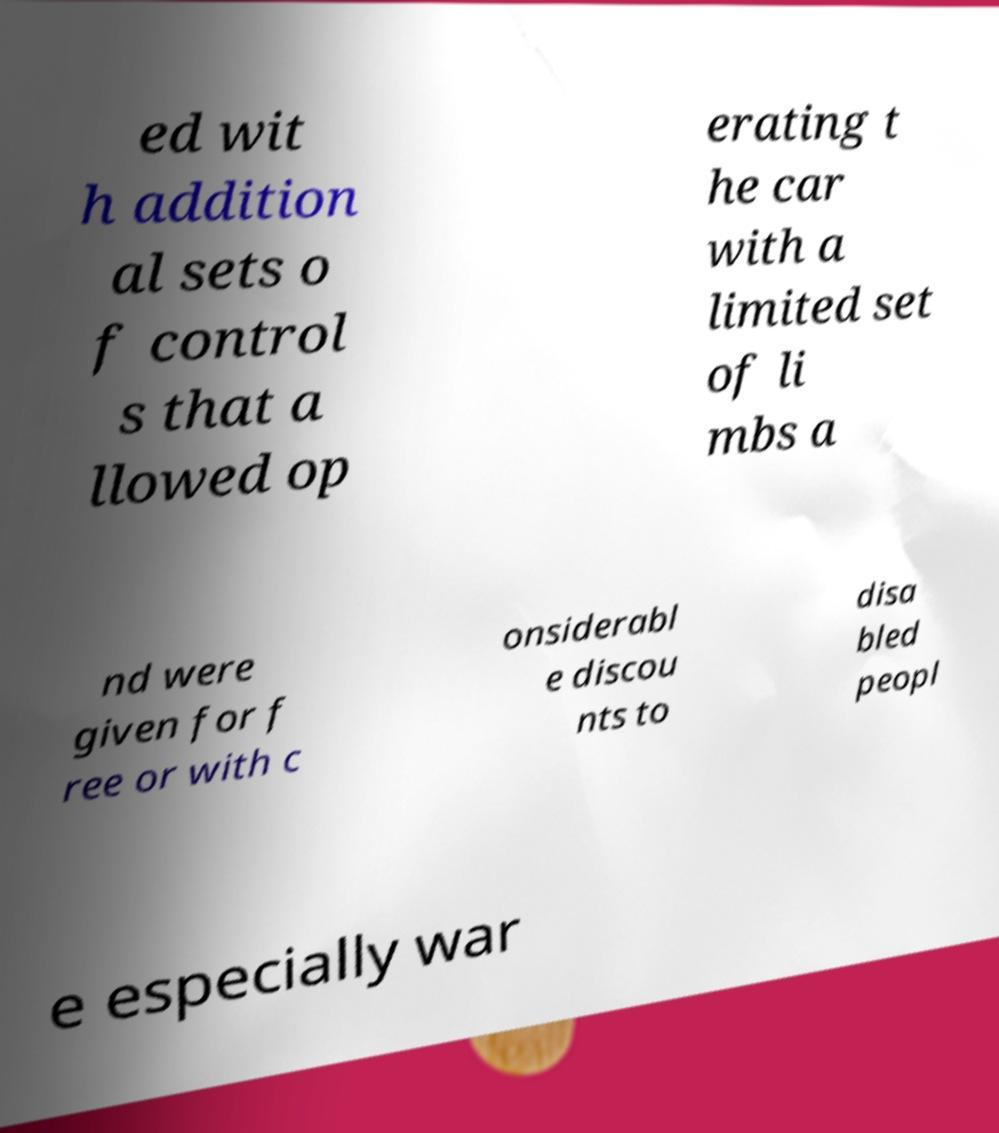I need the written content from this picture converted into text. Can you do that? ed wit h addition al sets o f control s that a llowed op erating t he car with a limited set of li mbs a nd were given for f ree or with c onsiderabl e discou nts to disa bled peopl e especially war 